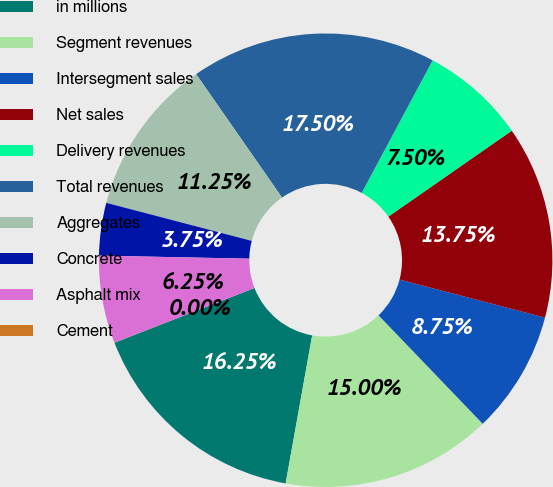Convert chart. <chart><loc_0><loc_0><loc_500><loc_500><pie_chart><fcel>in millions<fcel>Segment revenues<fcel>Intersegment sales<fcel>Net sales<fcel>Delivery revenues<fcel>Total revenues<fcel>Aggregates<fcel>Concrete<fcel>Asphalt mix<fcel>Cement<nl><fcel>16.25%<fcel>15.0%<fcel>8.75%<fcel>13.75%<fcel>7.5%<fcel>17.5%<fcel>11.25%<fcel>3.75%<fcel>6.25%<fcel>0.0%<nl></chart> 